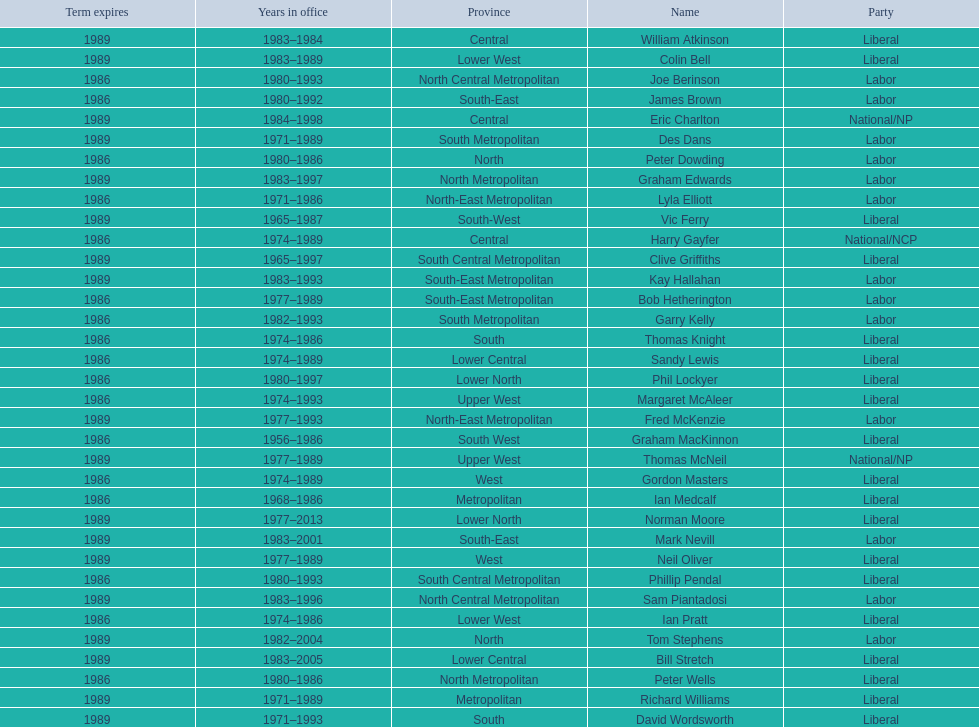Identify the final member mentioned with a surname starting with "p". Ian Pratt. 